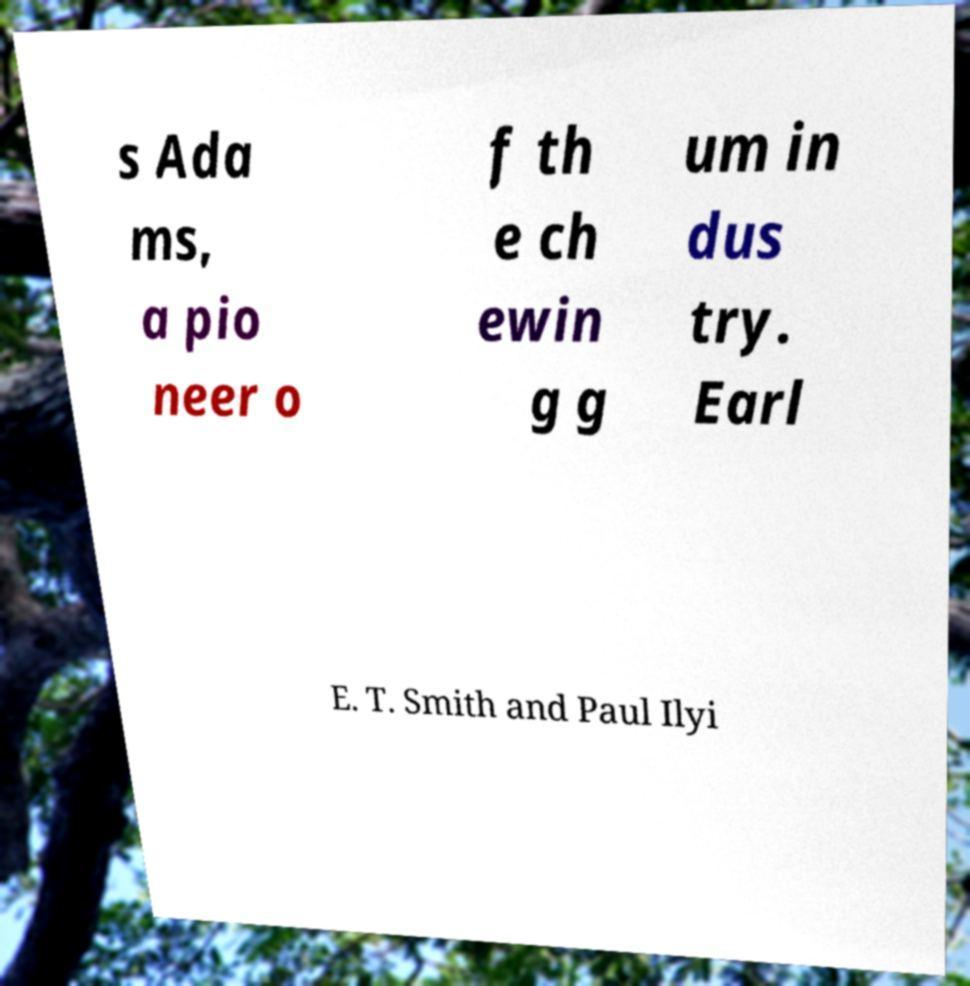Please identify and transcribe the text found in this image. s Ada ms, a pio neer o f th e ch ewin g g um in dus try. Earl E. T. Smith and Paul Ilyi 